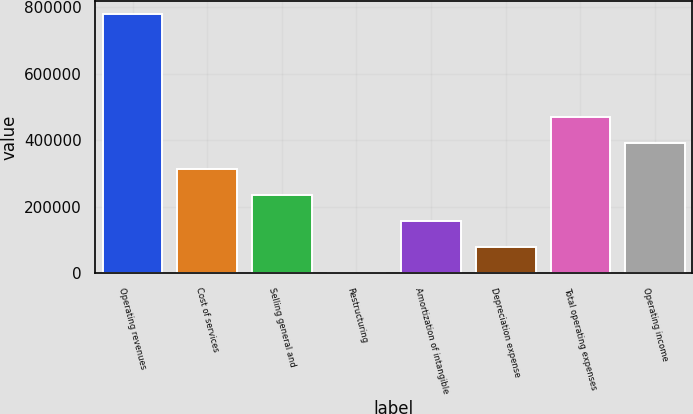<chart> <loc_0><loc_0><loc_500><loc_500><bar_chart><fcel>Operating revenues<fcel>Cost of services<fcel>Selling general and<fcel>Restructuring<fcel>Amortization of intangible<fcel>Depreciation expense<fcel>Total operating expenses<fcel>Operating income<nl><fcel>781355<fcel>313713<fcel>235772<fcel>1951<fcel>157832<fcel>79891.4<fcel>470851<fcel>391653<nl></chart> 